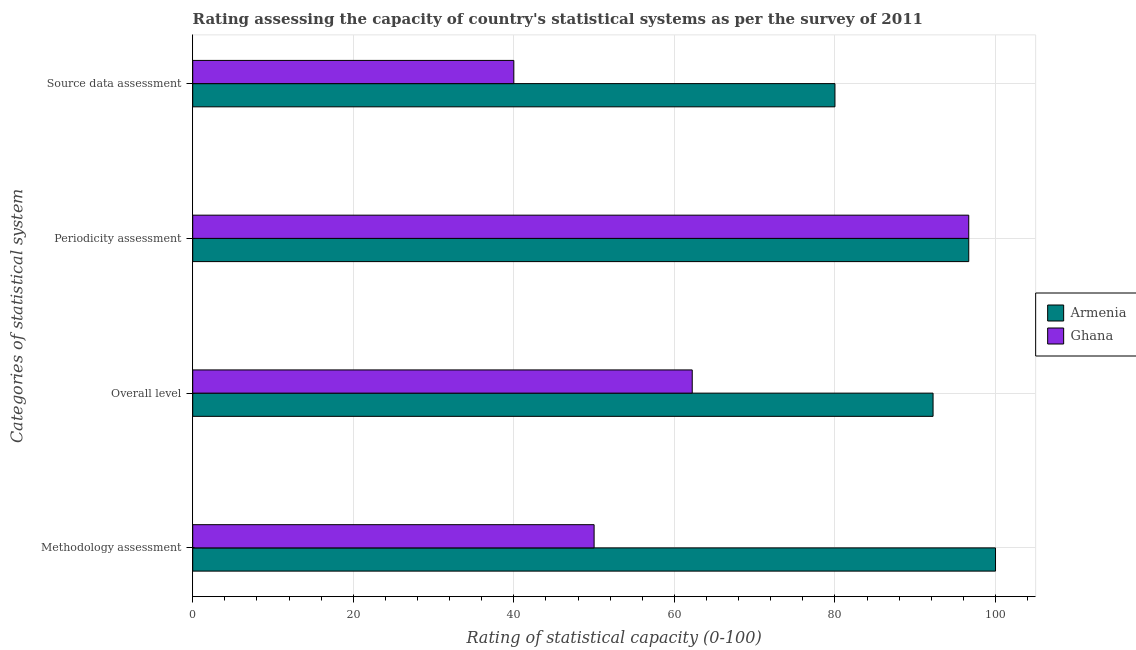How many groups of bars are there?
Your answer should be very brief. 4. Are the number of bars per tick equal to the number of legend labels?
Offer a terse response. Yes. How many bars are there on the 1st tick from the bottom?
Ensure brevity in your answer.  2. What is the label of the 4th group of bars from the top?
Provide a succinct answer. Methodology assessment. What is the source data assessment rating in Armenia?
Offer a very short reply. 80. Across all countries, what is the maximum methodology assessment rating?
Provide a short and direct response. 100. In which country was the periodicity assessment rating maximum?
Ensure brevity in your answer.  Armenia. In which country was the periodicity assessment rating minimum?
Your response must be concise. Armenia. What is the total periodicity assessment rating in the graph?
Your answer should be compact. 193.33. What is the difference between the methodology assessment rating in Armenia and that in Ghana?
Your answer should be compact. 50. What is the difference between the overall level rating in Armenia and the source data assessment rating in Ghana?
Keep it short and to the point. 52.22. What is the average periodicity assessment rating per country?
Make the answer very short. 96.67. What is the difference between the periodicity assessment rating and source data assessment rating in Armenia?
Give a very brief answer. 16.67. In how many countries, is the periodicity assessment rating greater than 80 ?
Provide a succinct answer. 2. What is the ratio of the methodology assessment rating in Armenia to that in Ghana?
Offer a terse response. 2. Is the methodology assessment rating in Armenia less than that in Ghana?
Your answer should be compact. No. What is the difference between the highest and the second highest source data assessment rating?
Your response must be concise. 40. What is the difference between the highest and the lowest overall level rating?
Offer a very short reply. 30. What does the 2nd bar from the top in Periodicity assessment represents?
Offer a very short reply. Armenia. What does the 1st bar from the bottom in Periodicity assessment represents?
Give a very brief answer. Armenia. Is it the case that in every country, the sum of the methodology assessment rating and overall level rating is greater than the periodicity assessment rating?
Give a very brief answer. Yes. How many bars are there?
Offer a terse response. 8. How many countries are there in the graph?
Make the answer very short. 2. What is the difference between two consecutive major ticks on the X-axis?
Your response must be concise. 20. Are the values on the major ticks of X-axis written in scientific E-notation?
Give a very brief answer. No. Does the graph contain any zero values?
Provide a succinct answer. No. Where does the legend appear in the graph?
Offer a terse response. Center right. How many legend labels are there?
Your answer should be compact. 2. How are the legend labels stacked?
Keep it short and to the point. Vertical. What is the title of the graph?
Provide a short and direct response. Rating assessing the capacity of country's statistical systems as per the survey of 2011 . What is the label or title of the X-axis?
Ensure brevity in your answer.  Rating of statistical capacity (0-100). What is the label or title of the Y-axis?
Your response must be concise. Categories of statistical system. What is the Rating of statistical capacity (0-100) in Armenia in Methodology assessment?
Your answer should be very brief. 100. What is the Rating of statistical capacity (0-100) in Ghana in Methodology assessment?
Your response must be concise. 50. What is the Rating of statistical capacity (0-100) of Armenia in Overall level?
Your answer should be compact. 92.22. What is the Rating of statistical capacity (0-100) of Ghana in Overall level?
Your answer should be very brief. 62.22. What is the Rating of statistical capacity (0-100) of Armenia in Periodicity assessment?
Make the answer very short. 96.67. What is the Rating of statistical capacity (0-100) in Ghana in Periodicity assessment?
Your answer should be compact. 96.67. Across all Categories of statistical system, what is the maximum Rating of statistical capacity (0-100) of Armenia?
Keep it short and to the point. 100. Across all Categories of statistical system, what is the maximum Rating of statistical capacity (0-100) of Ghana?
Your response must be concise. 96.67. Across all Categories of statistical system, what is the minimum Rating of statistical capacity (0-100) of Armenia?
Provide a succinct answer. 80. What is the total Rating of statistical capacity (0-100) of Armenia in the graph?
Make the answer very short. 368.89. What is the total Rating of statistical capacity (0-100) in Ghana in the graph?
Provide a succinct answer. 248.89. What is the difference between the Rating of statistical capacity (0-100) of Armenia in Methodology assessment and that in Overall level?
Give a very brief answer. 7.78. What is the difference between the Rating of statistical capacity (0-100) of Ghana in Methodology assessment and that in Overall level?
Make the answer very short. -12.22. What is the difference between the Rating of statistical capacity (0-100) in Armenia in Methodology assessment and that in Periodicity assessment?
Offer a very short reply. 3.33. What is the difference between the Rating of statistical capacity (0-100) in Ghana in Methodology assessment and that in Periodicity assessment?
Give a very brief answer. -46.67. What is the difference between the Rating of statistical capacity (0-100) in Armenia in Methodology assessment and that in Source data assessment?
Make the answer very short. 20. What is the difference between the Rating of statistical capacity (0-100) in Ghana in Methodology assessment and that in Source data assessment?
Make the answer very short. 10. What is the difference between the Rating of statistical capacity (0-100) of Armenia in Overall level and that in Periodicity assessment?
Your answer should be compact. -4.44. What is the difference between the Rating of statistical capacity (0-100) of Ghana in Overall level and that in Periodicity assessment?
Your answer should be very brief. -34.44. What is the difference between the Rating of statistical capacity (0-100) of Armenia in Overall level and that in Source data assessment?
Your answer should be compact. 12.22. What is the difference between the Rating of statistical capacity (0-100) in Ghana in Overall level and that in Source data assessment?
Ensure brevity in your answer.  22.22. What is the difference between the Rating of statistical capacity (0-100) of Armenia in Periodicity assessment and that in Source data assessment?
Your answer should be very brief. 16.67. What is the difference between the Rating of statistical capacity (0-100) of Ghana in Periodicity assessment and that in Source data assessment?
Your response must be concise. 56.67. What is the difference between the Rating of statistical capacity (0-100) of Armenia in Methodology assessment and the Rating of statistical capacity (0-100) of Ghana in Overall level?
Offer a very short reply. 37.78. What is the difference between the Rating of statistical capacity (0-100) in Armenia in Methodology assessment and the Rating of statistical capacity (0-100) in Ghana in Source data assessment?
Ensure brevity in your answer.  60. What is the difference between the Rating of statistical capacity (0-100) in Armenia in Overall level and the Rating of statistical capacity (0-100) in Ghana in Periodicity assessment?
Offer a very short reply. -4.44. What is the difference between the Rating of statistical capacity (0-100) of Armenia in Overall level and the Rating of statistical capacity (0-100) of Ghana in Source data assessment?
Ensure brevity in your answer.  52.22. What is the difference between the Rating of statistical capacity (0-100) of Armenia in Periodicity assessment and the Rating of statistical capacity (0-100) of Ghana in Source data assessment?
Provide a succinct answer. 56.67. What is the average Rating of statistical capacity (0-100) in Armenia per Categories of statistical system?
Keep it short and to the point. 92.22. What is the average Rating of statistical capacity (0-100) in Ghana per Categories of statistical system?
Provide a succinct answer. 62.22. What is the difference between the Rating of statistical capacity (0-100) in Armenia and Rating of statistical capacity (0-100) in Ghana in Overall level?
Ensure brevity in your answer.  30. What is the difference between the Rating of statistical capacity (0-100) in Armenia and Rating of statistical capacity (0-100) in Ghana in Source data assessment?
Provide a succinct answer. 40. What is the ratio of the Rating of statistical capacity (0-100) of Armenia in Methodology assessment to that in Overall level?
Provide a succinct answer. 1.08. What is the ratio of the Rating of statistical capacity (0-100) of Ghana in Methodology assessment to that in Overall level?
Make the answer very short. 0.8. What is the ratio of the Rating of statistical capacity (0-100) of Armenia in Methodology assessment to that in Periodicity assessment?
Provide a succinct answer. 1.03. What is the ratio of the Rating of statistical capacity (0-100) in Ghana in Methodology assessment to that in Periodicity assessment?
Your answer should be compact. 0.52. What is the ratio of the Rating of statistical capacity (0-100) in Ghana in Methodology assessment to that in Source data assessment?
Your answer should be compact. 1.25. What is the ratio of the Rating of statistical capacity (0-100) of Armenia in Overall level to that in Periodicity assessment?
Your response must be concise. 0.95. What is the ratio of the Rating of statistical capacity (0-100) of Ghana in Overall level to that in Periodicity assessment?
Offer a terse response. 0.64. What is the ratio of the Rating of statistical capacity (0-100) of Armenia in Overall level to that in Source data assessment?
Ensure brevity in your answer.  1.15. What is the ratio of the Rating of statistical capacity (0-100) in Ghana in Overall level to that in Source data assessment?
Your answer should be very brief. 1.56. What is the ratio of the Rating of statistical capacity (0-100) of Armenia in Periodicity assessment to that in Source data assessment?
Your answer should be very brief. 1.21. What is the ratio of the Rating of statistical capacity (0-100) in Ghana in Periodicity assessment to that in Source data assessment?
Your response must be concise. 2.42. What is the difference between the highest and the second highest Rating of statistical capacity (0-100) of Armenia?
Your answer should be very brief. 3.33. What is the difference between the highest and the second highest Rating of statistical capacity (0-100) of Ghana?
Offer a very short reply. 34.44. What is the difference between the highest and the lowest Rating of statistical capacity (0-100) in Ghana?
Keep it short and to the point. 56.67. 